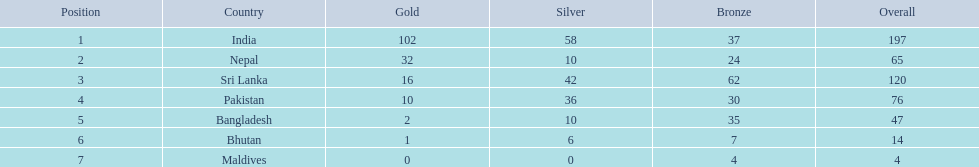What are the totals of medals one in each country? 197, 65, 120, 76, 47, 14, 4. Which of these totals are less than 10? 4. Who won this number of medals? Maldives. 